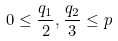Convert formula to latex. <formula><loc_0><loc_0><loc_500><loc_500>0 \leq \frac { q _ { 1 } } { 2 } , \frac { q _ { 2 } } { 3 } \leq p</formula> 